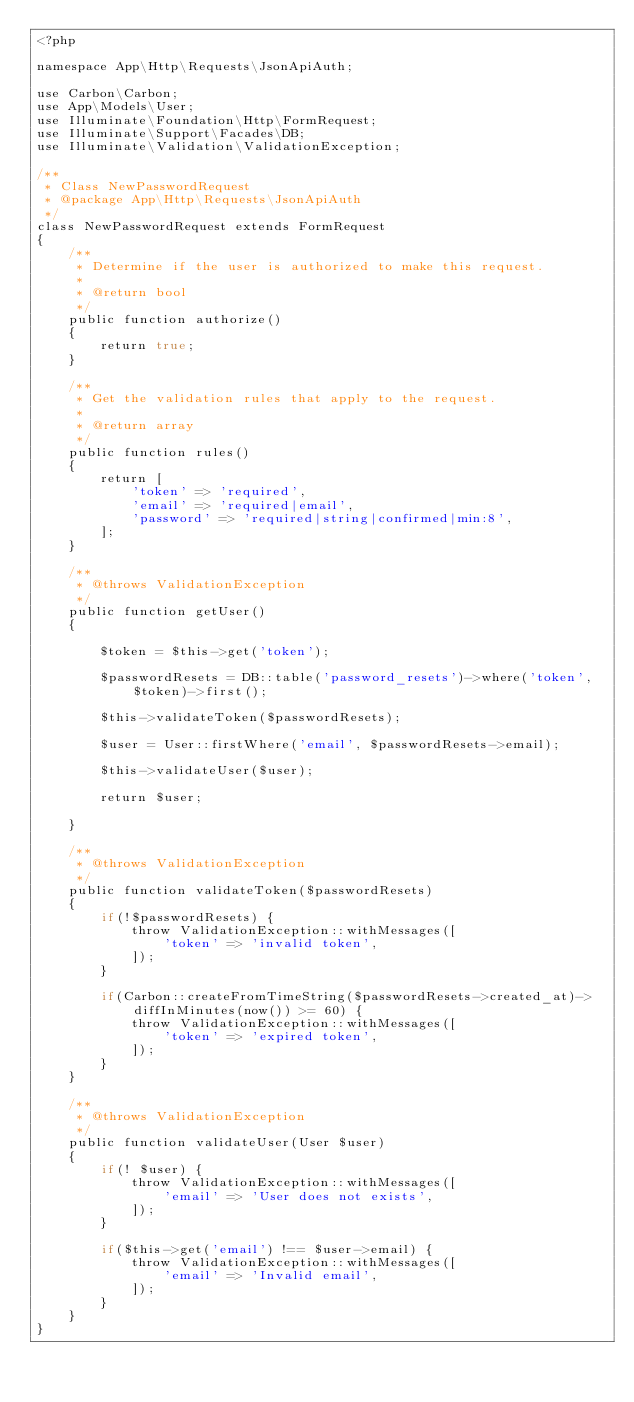Convert code to text. <code><loc_0><loc_0><loc_500><loc_500><_PHP_><?php

namespace App\Http\Requests\JsonApiAuth;

use Carbon\Carbon;
use App\Models\User;
use Illuminate\Foundation\Http\FormRequest;
use Illuminate\Support\Facades\DB;
use Illuminate\Validation\ValidationException;

/**
 * Class NewPasswordRequest
 * @package App\Http\Requests\JsonApiAuth
 */
class NewPasswordRequest extends FormRequest
{
    /**
     * Determine if the user is authorized to make this request.
     *
     * @return bool
     */
    public function authorize()
    {
        return true;
    }

    /**
     * Get the validation rules that apply to the request.
     *
     * @return array
     */
    public function rules()
    {
        return [
            'token' => 'required',
            'email' => 'required|email',
            'password' => 'required|string|confirmed|min:8',
        ];
    }

    /**
     * @throws ValidationException
     */
    public function getUser()
    {

        $token = $this->get('token');

        $passwordResets = DB::table('password_resets')->where('token', $token)->first();

        $this->validateToken($passwordResets);

        $user = User::firstWhere('email', $passwordResets->email);

        $this->validateUser($user);

        return $user;

    }

    /**
     * @throws ValidationException
     */
    public function validateToken($passwordResets)
    {
        if(!$passwordResets) {
            throw ValidationException::withMessages([
                'token' => 'invalid token',
            ]);
        }

        if(Carbon::createFromTimeString($passwordResets->created_at)->diffInMinutes(now()) >= 60) {
            throw ValidationException::withMessages([
                'token' => 'expired token',
            ]);
        }
    }

    /**
     * @throws ValidationException
     */
    public function validateUser(User $user)
    {
        if(! $user) {
            throw ValidationException::withMessages([
                'email' => 'User does not exists',
            ]);
        }

        if($this->get('email') !== $user->email) {
            throw ValidationException::withMessages([
                'email' => 'Invalid email',
            ]);
        }
    }
}
</code> 